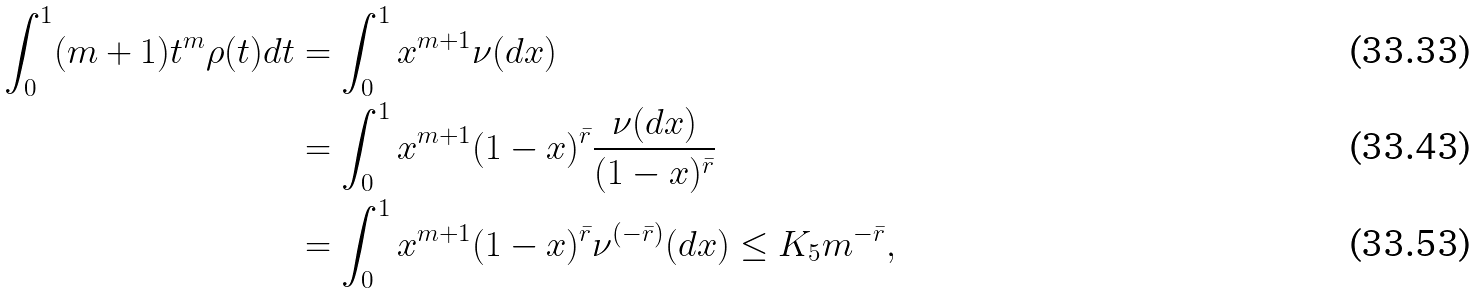<formula> <loc_0><loc_0><loc_500><loc_500>\int _ { 0 } ^ { 1 } ( m + 1 ) t ^ { m } \rho ( t ) d t & = \int _ { 0 } ^ { 1 } x ^ { m + 1 } \nu ( d x ) \\ & = \int _ { 0 } ^ { 1 } x ^ { m + 1 } ( 1 - x ) ^ { \bar { r } } \frac { \nu ( d x ) } { ( 1 - x ) ^ { \bar { r } } } \\ & = \int _ { 0 } ^ { 1 } x ^ { m + 1 } ( 1 - x ) ^ { \bar { r } } \nu ^ { ( - \bar { r } ) } ( d x ) \leq K _ { 5 } m ^ { - \bar { r } } ,</formula> 